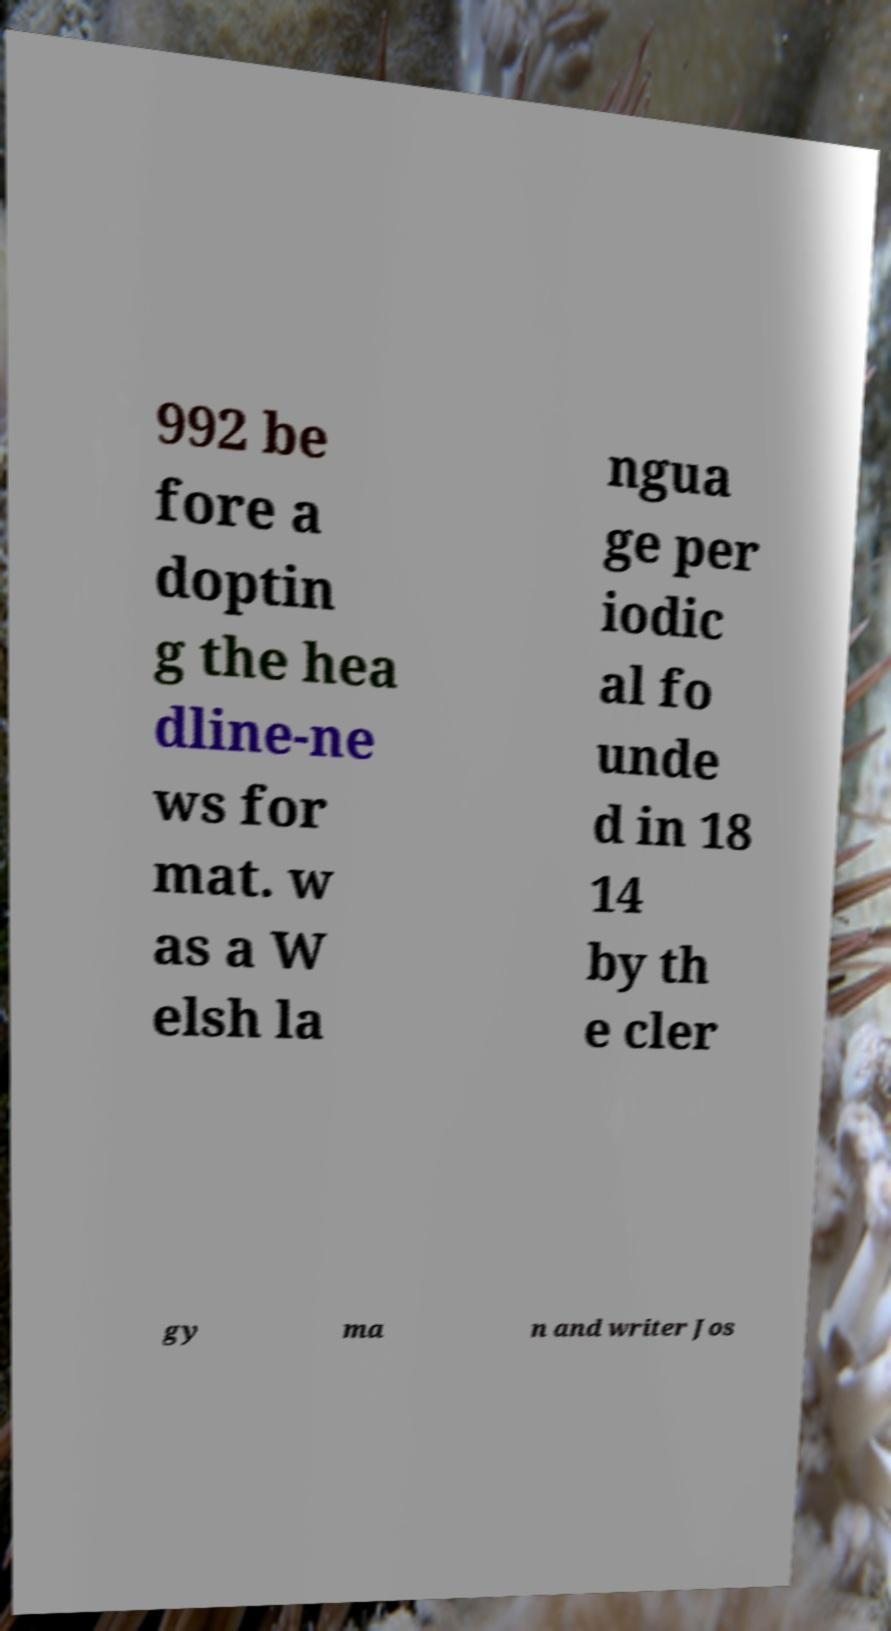I need the written content from this picture converted into text. Can you do that? 992 be fore a doptin g the hea dline-ne ws for mat. w as a W elsh la ngua ge per iodic al fo unde d in 18 14 by th e cler gy ma n and writer Jos 